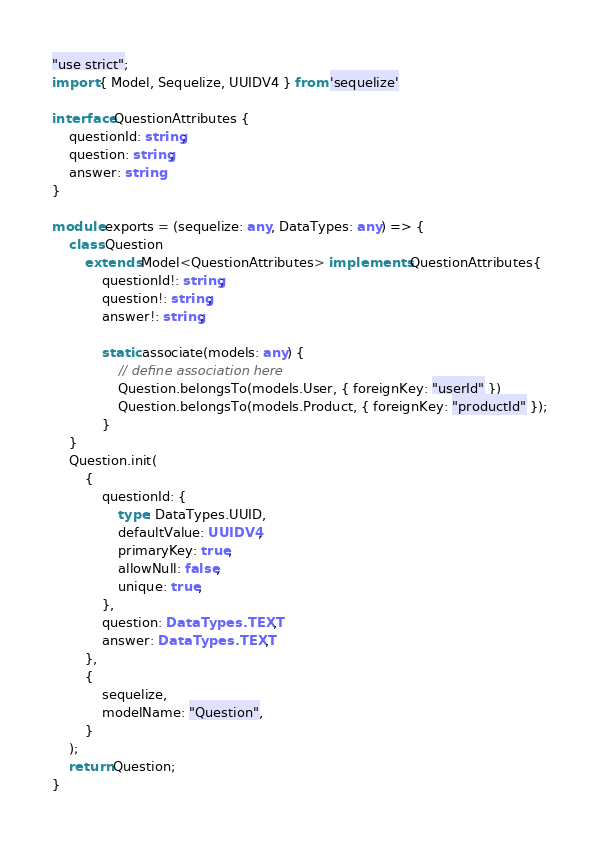Convert code to text. <code><loc_0><loc_0><loc_500><loc_500><_TypeScript_>"use strict";
import { Model, Sequelize, UUIDV4 } from 'sequelize'

interface QuestionAttributes {
    questionId: string;
    question: string;
    answer: string
}

module.exports = (sequelize: any, DataTypes: any) => {
    class Question
        extends Model<QuestionAttributes> implements QuestionAttributes{
            questionId!: string;
            question!: string;
            answer!: string;

            static associate(models: any) {
                // define association here
                Question.belongsTo(models.User, { foreignKey: "userId" })
                Question.belongsTo(models.Product, { foreignKey: "productId" });
            }
    }
    Question.init(
        {
            questionId: {
                type: DataTypes.UUID,
                defaultValue: UUIDV4,
                primaryKey: true,
                allowNull: false,
                unique: true,           
            },
            question: DataTypes.TEXT,
            answer: DataTypes.TEXT,
        },
        {
            sequelize,
            modelName: "Question",
        }
    );
    return Question;
}
</code> 